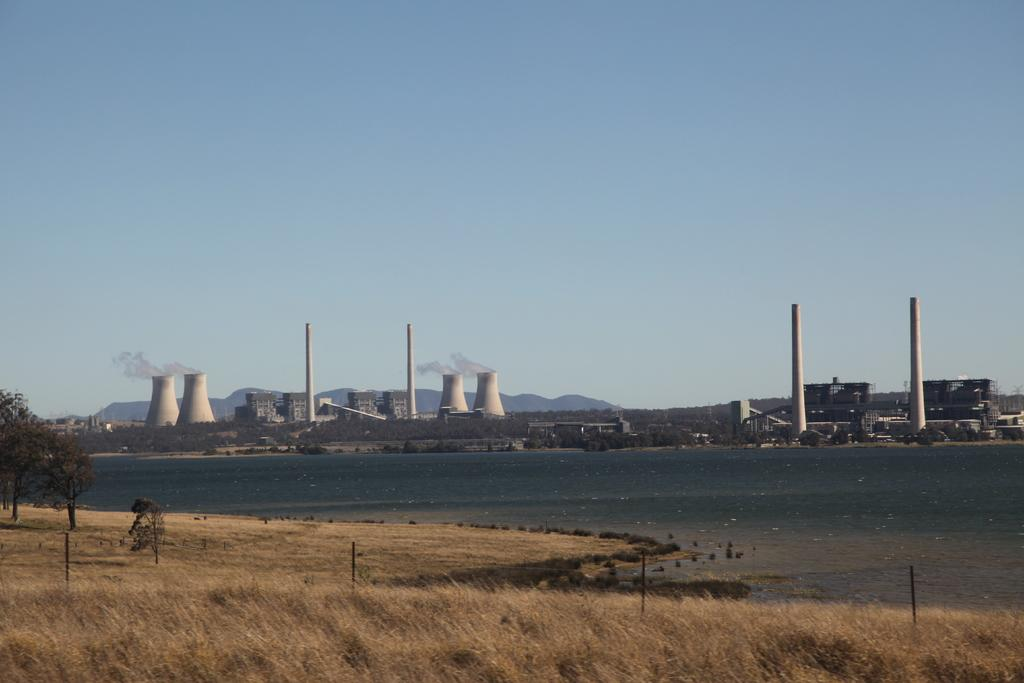What type of vegetation can be seen in the foreground of the image? There is grass in the foreground of the image. What structures are present in the foreground of the image? There is a fence and houses in the foreground of the image. What natural elements can be seen in the foreground of the image? There are trees and water visible in the foreground of the image. What can be seen in the background of the image? There are power plants, mountains, and the sky visible in the background of the image. Can you describe the time of day when the image was taken? The image is likely taken during the day, as the sky is visible. What type of fang can be seen in the image? There is no fang present in the image. What season is depicted in the image? The image does not depict a specific season, as there are no seasonal indicators present. 